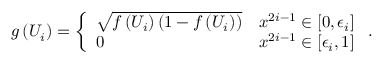<formula> <loc_0><loc_0><loc_500><loc_500>g \left ( U _ { i } \right ) = \left \{ \begin{array} { l l } { { \sqrt { f \left ( U _ { i } \right ) \left ( 1 - f \left ( U _ { i } \right ) \right ) } } } & { { x ^ { 2 i - 1 } \in \left [ 0 , \epsilon _ { i } \right ] } } \\ { 0 } & { { x ^ { 2 i - 1 } \in \left [ \epsilon _ { i } , 1 \right ] } } \end{array} .</formula> 